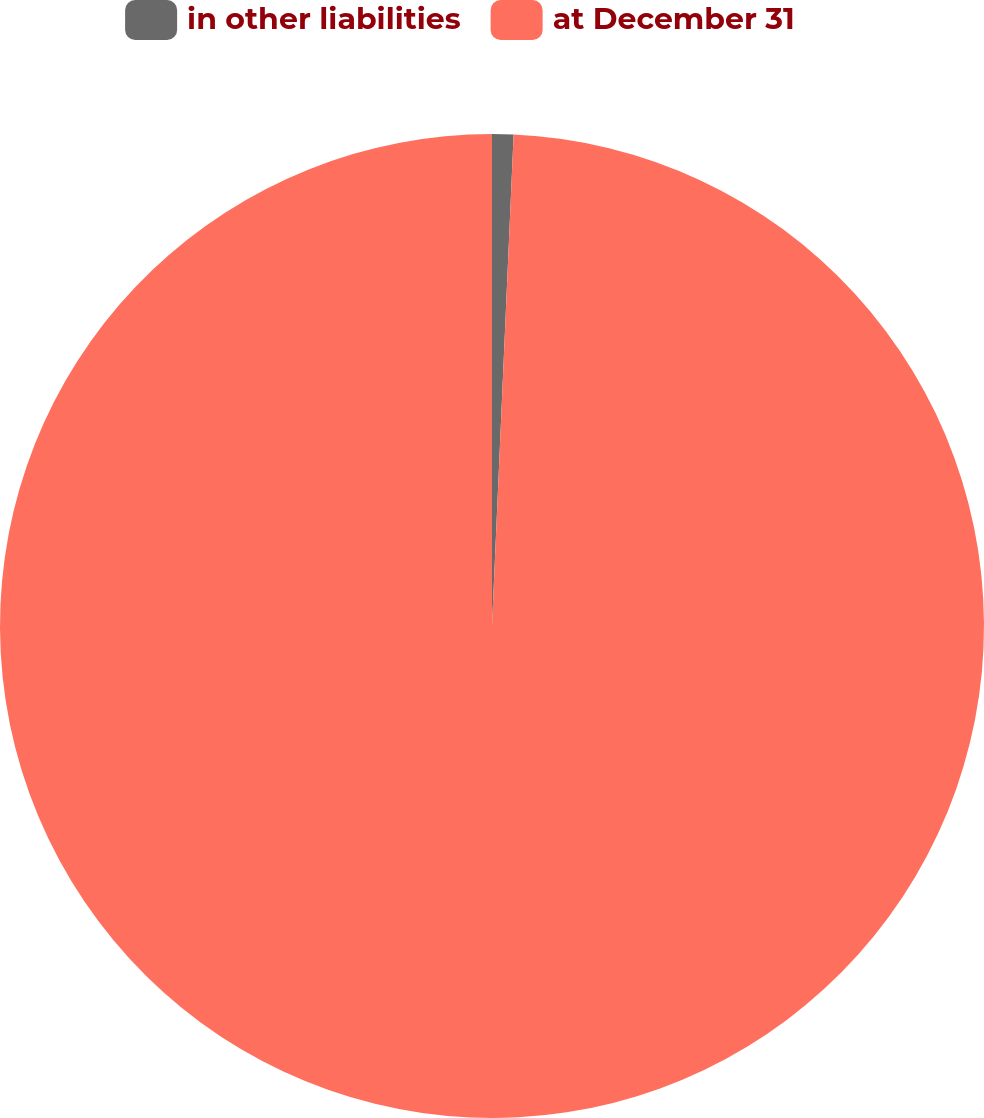<chart> <loc_0><loc_0><loc_500><loc_500><pie_chart><fcel>in other liabilities<fcel>at December 31<nl><fcel>0.7%<fcel>99.3%<nl></chart> 